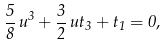<formula> <loc_0><loc_0><loc_500><loc_500>\frac { 5 } { 8 } \, u ^ { 3 } + \frac { 3 } { 2 } \, u t _ { 3 } + t _ { 1 } = 0 ,</formula> 